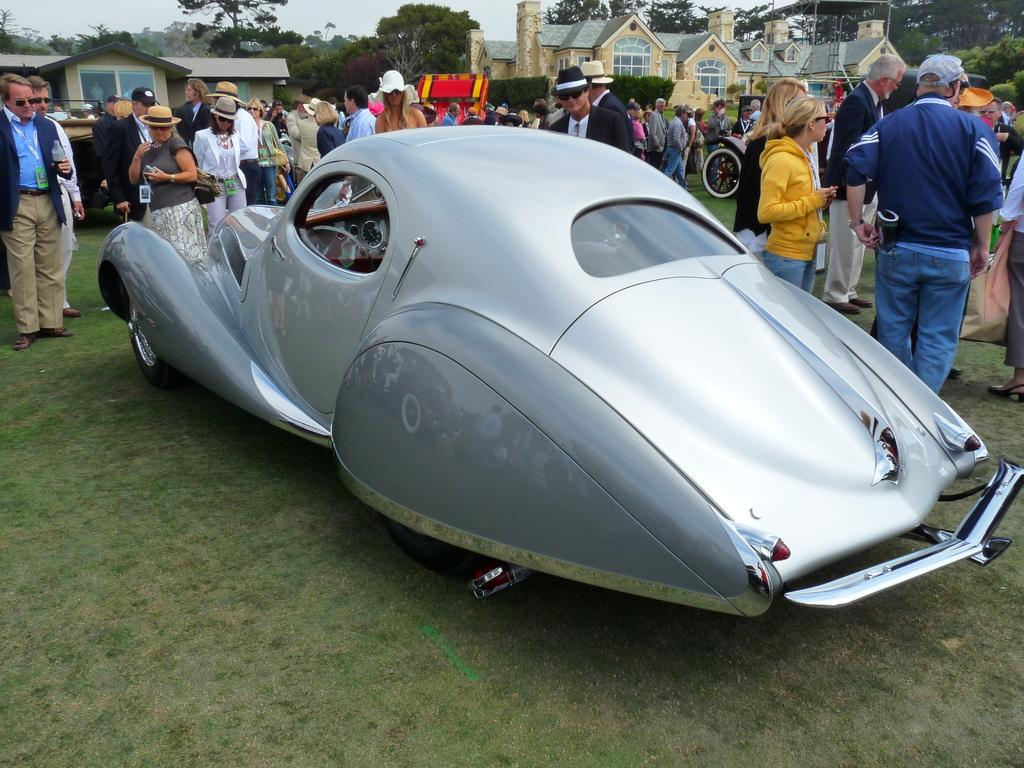What is the main subject of the image? The main subject of the image is a car. What else can be seen in the image besides the car? There are men and women standing, houses, trees, and the sky visible in the image. Can you describe the people in the image? The people in the image are men and women standing. What type of natural elements are present in the image? Trees are the natural elements present in the image. What type of zinc is being used to build the houses in the image? There is no mention of zinc being used to build the houses in the image. The houses are simply present in the image, and their construction materials are not specified. 